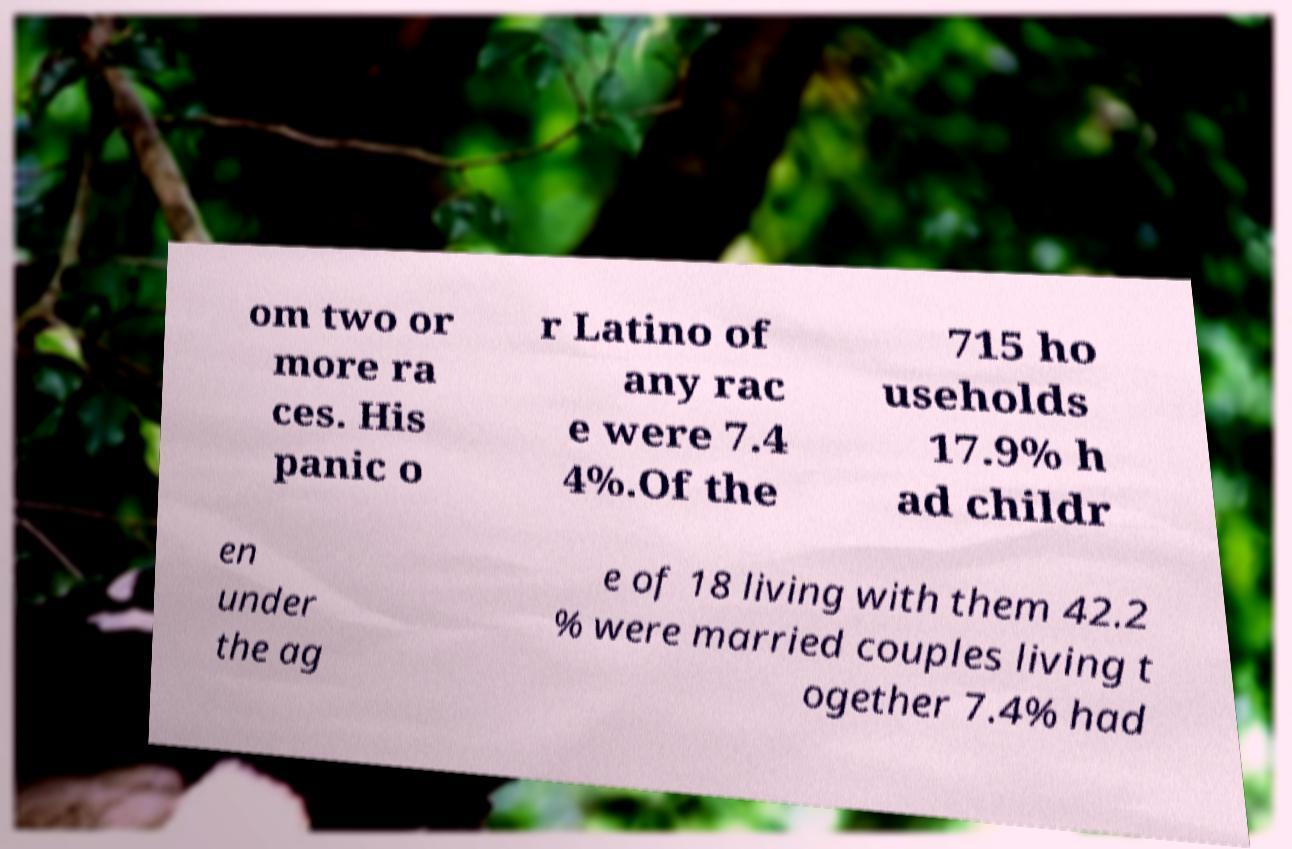There's text embedded in this image that I need extracted. Can you transcribe it verbatim? om two or more ra ces. His panic o r Latino of any rac e were 7.4 4%.Of the 715 ho useholds 17.9% h ad childr en under the ag e of 18 living with them 42.2 % were married couples living t ogether 7.4% had 